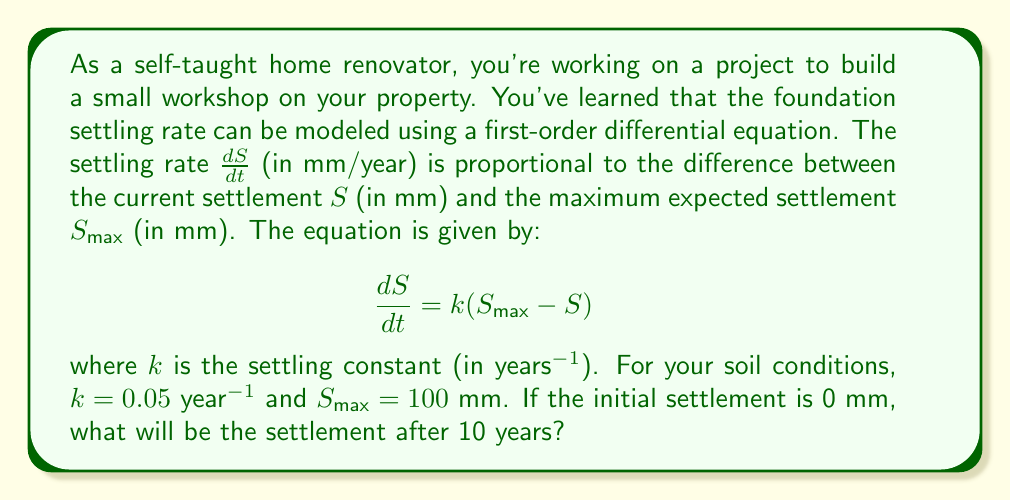Show me your answer to this math problem. To solve this first-order differential equation, we can follow these steps:

1) The general form of the equation is:
   $$\frac{dS}{dt} = k(S_{max} - S)$$

2) This is a separable equation. We can rearrange it as:
   $$\frac{dS}{S_{max} - S} = k dt$$

3) Integrating both sides:
   $$\int \frac{dS}{S_{max} - S} = \int k dt$$

4) The left side integrates to $-\ln|S_{max} - S|$, and the right side to $kt + C$:
   $$-\ln|S_{max} - S| = kt + C$$

5) Solving for $S$:
   $$S = S_{max} - Ae^{-kt}$$
   where $A$ is a constant determined by the initial conditions.

6) Given the initial condition $S(0) = 0$, we can find $A$:
   $$0 = S_{max} - A$$
   $$A = S_{max} = 100$$

7) So our particular solution is:
   $$S = S_{max}(1 - e^{-kt}) = 100(1 - e^{-0.05t})$$

8) To find the settlement after 10 years, we substitute $t = 10$:
   $$S(10) = 100(1 - e^{-0.05 * 10}) = 100(1 - e^{-0.5})$$

9) Calculating this:
   $$S(10) = 100(1 - 0.6065) = 39.35$$ mm
Answer: The settlement after 10 years will be approximately 39.35 mm. 